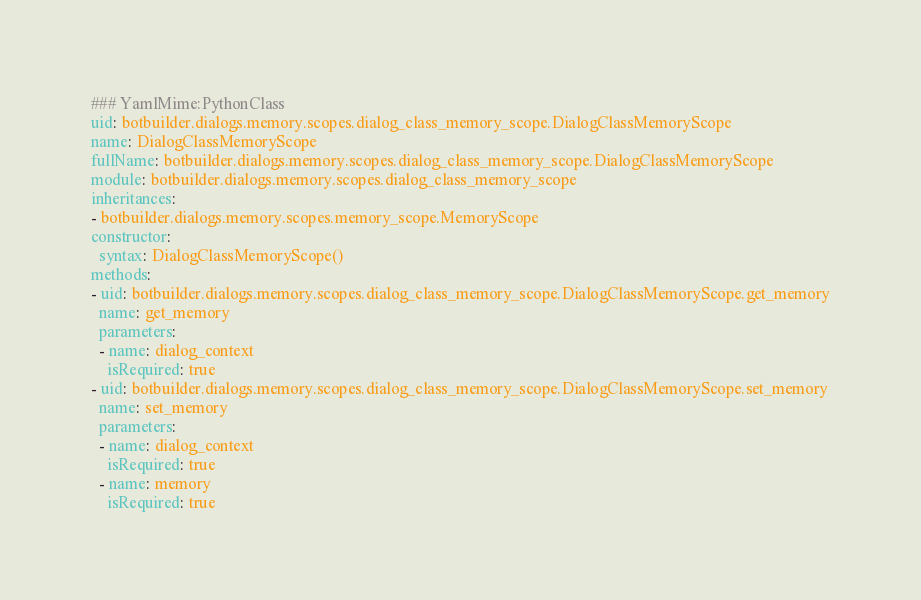Convert code to text. <code><loc_0><loc_0><loc_500><loc_500><_YAML_>### YamlMime:PythonClass
uid: botbuilder.dialogs.memory.scopes.dialog_class_memory_scope.DialogClassMemoryScope
name: DialogClassMemoryScope
fullName: botbuilder.dialogs.memory.scopes.dialog_class_memory_scope.DialogClassMemoryScope
module: botbuilder.dialogs.memory.scopes.dialog_class_memory_scope
inheritances:
- botbuilder.dialogs.memory.scopes.memory_scope.MemoryScope
constructor:
  syntax: DialogClassMemoryScope()
methods:
- uid: botbuilder.dialogs.memory.scopes.dialog_class_memory_scope.DialogClassMemoryScope.get_memory
  name: get_memory
  parameters:
  - name: dialog_context
    isRequired: true
- uid: botbuilder.dialogs.memory.scopes.dialog_class_memory_scope.DialogClassMemoryScope.set_memory
  name: set_memory
  parameters:
  - name: dialog_context
    isRequired: true
  - name: memory
    isRequired: true
</code> 